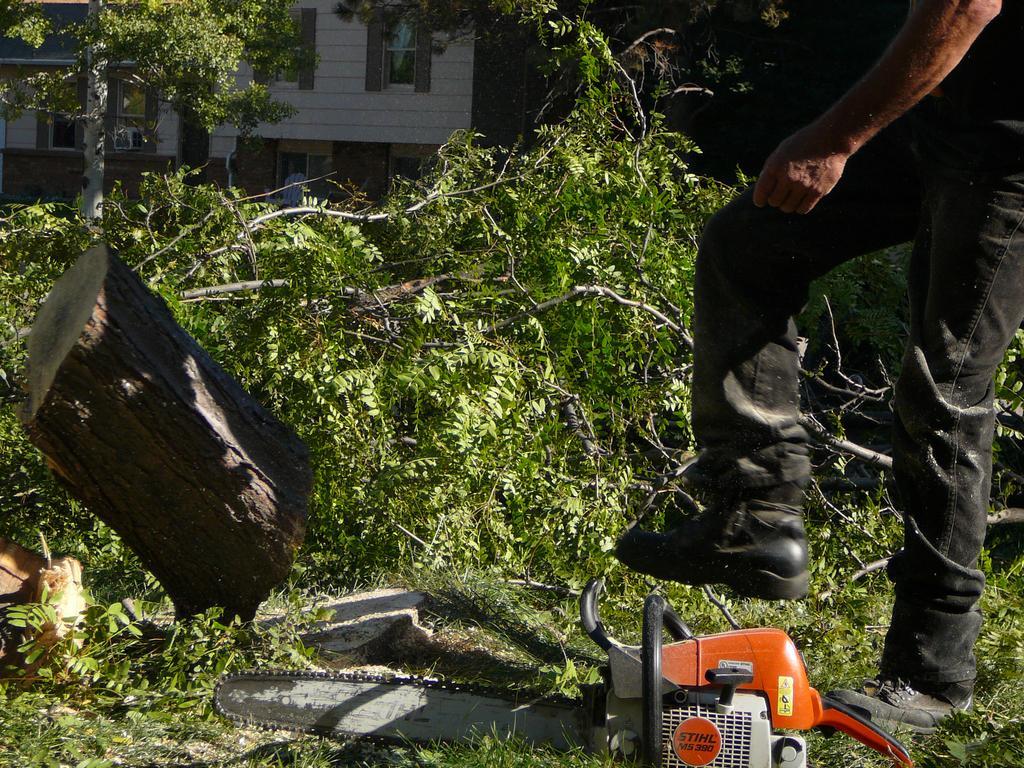How would you summarize this image in a sentence or two? In this image we can see a saw and a person standing on the ground. We can also see some wooden logs and some branches of trees. On the backside we can see a tree and a building with windows. 